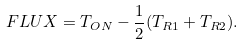Convert formula to latex. <formula><loc_0><loc_0><loc_500><loc_500>F L U X = T _ { O N } - \frac { 1 } { 2 } ( T _ { R 1 } + T _ { R 2 } ) .</formula> 